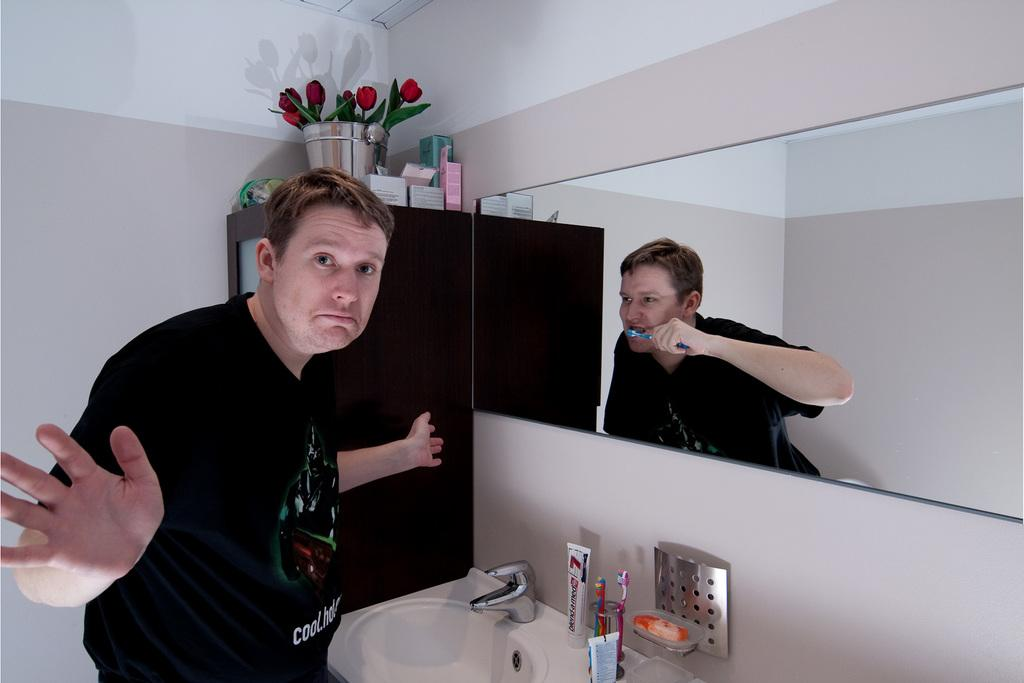How many people are in the image? There are two members in the image. What can be observed about the appearance of the two members? The two members look similar. What can be seen at the bottom of the picture? There is a sink in the bottom of the picture. What is connected to the sink? There is a tap associated with the sink. What is visible in the background of the image? There is a wall in the background of the image. What type of brass instrument is being played by the members in the image? There is no brass instrument present in the image; it features two members and a sink with a tap. On which side of the sink is the tap located? The image does not specify the side of the sink where the tap is located. 